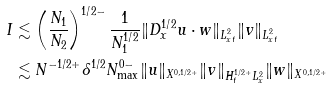Convert formula to latex. <formula><loc_0><loc_0><loc_500><loc_500>I & \lesssim \left ( \frac { N _ { 1 } } { N _ { 2 } } \right ) ^ { 1 / 2 - } \frac { 1 } { N _ { 1 } ^ { 1 / 2 } } \| D _ { x } ^ { 1 / 2 } u \cdot w \| _ { L _ { x t } ^ { 2 } } \| v \| _ { L _ { x t } ^ { 2 } } \\ & \lesssim N ^ { - 1 / 2 + } \delta ^ { 1 / 2 } N _ { \max } ^ { 0 - } \| u \| _ { X ^ { 0 , 1 / 2 + } } \| v \| _ { H _ { t } ^ { 1 / 2 + } L _ { x } ^ { 2 } } \| w \| _ { X ^ { 0 , 1 / 2 + } }</formula> 